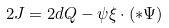<formula> <loc_0><loc_0><loc_500><loc_500>2 J = 2 d Q - \psi \xi \cdot ( { * } \Psi )</formula> 